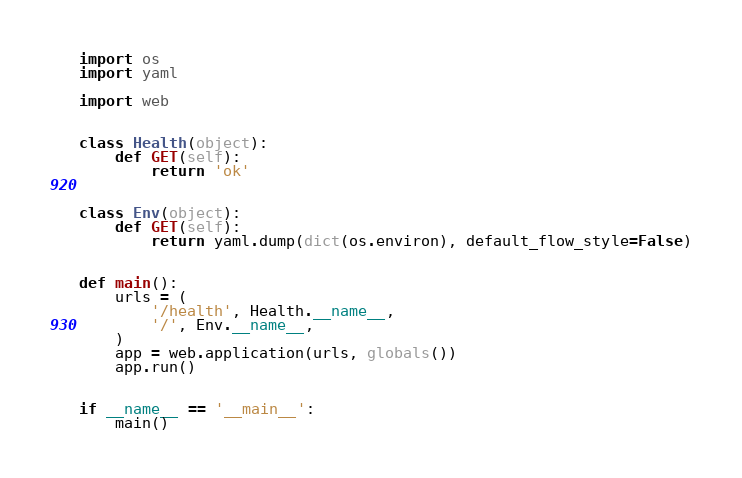Convert code to text. <code><loc_0><loc_0><loc_500><loc_500><_Python_>import os
import yaml

import web


class Health(object):
    def GET(self):
        return 'ok'


class Env(object):
    def GET(self):
        return yaml.dump(dict(os.environ), default_flow_style=False)


def main():
    urls = (
        '/health', Health.__name__,
        '/', Env.__name__,
    )
    app = web.application(urls, globals())
    app.run()


if __name__ == '__main__':
    main()
</code> 